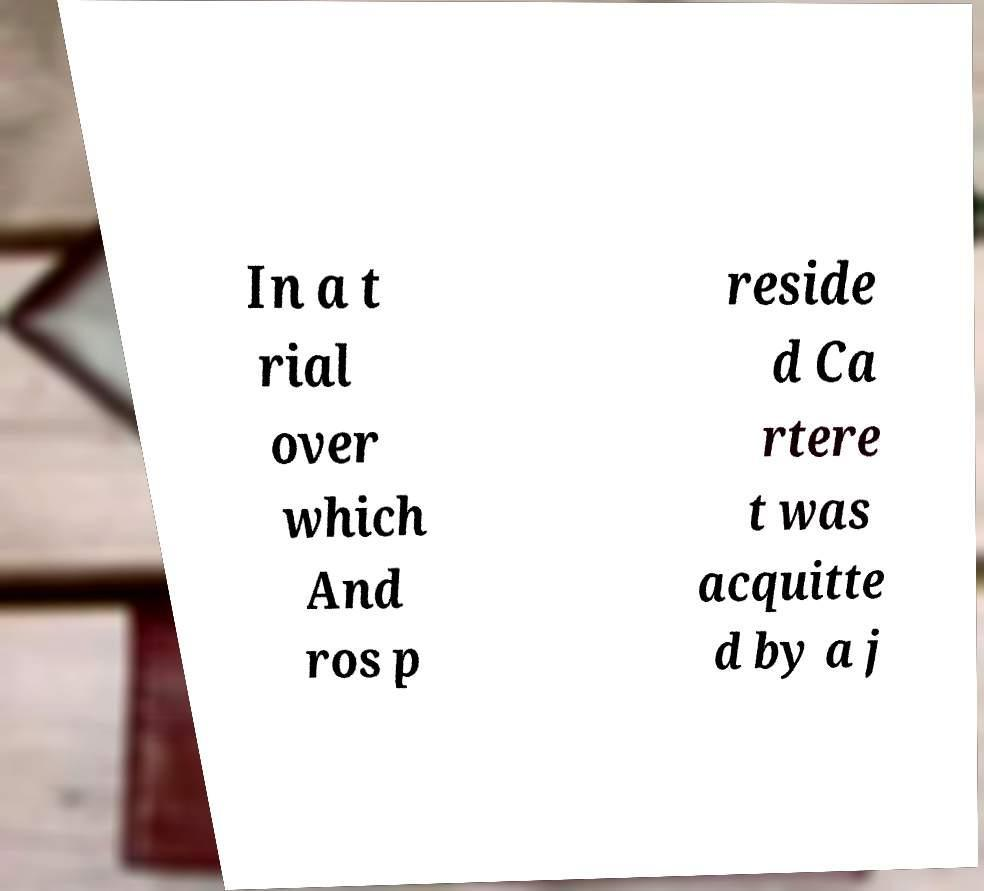What messages or text are displayed in this image? I need them in a readable, typed format. In a t rial over which And ros p reside d Ca rtere t was acquitte d by a j 